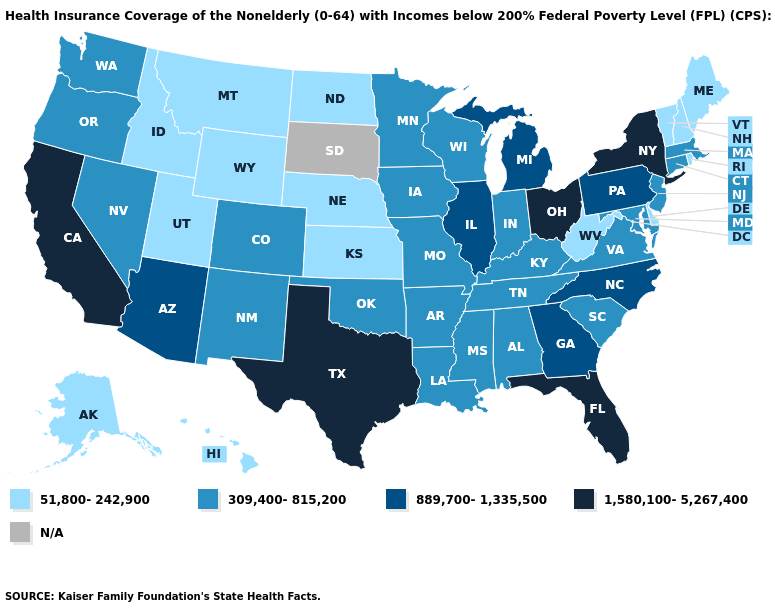Among the states that border Nebraska , does Wyoming have the highest value?
Write a very short answer. No. What is the lowest value in the USA?
Answer briefly. 51,800-242,900. What is the value of Colorado?
Write a very short answer. 309,400-815,200. What is the lowest value in states that border Alabama?
Quick response, please. 309,400-815,200. Name the states that have a value in the range N/A?
Keep it brief. South Dakota. What is the highest value in the USA?
Answer briefly. 1,580,100-5,267,400. What is the highest value in the USA?
Be succinct. 1,580,100-5,267,400. Which states have the lowest value in the USA?
Be succinct. Alaska, Delaware, Hawaii, Idaho, Kansas, Maine, Montana, Nebraska, New Hampshire, North Dakota, Rhode Island, Utah, Vermont, West Virginia, Wyoming. Name the states that have a value in the range 51,800-242,900?
Keep it brief. Alaska, Delaware, Hawaii, Idaho, Kansas, Maine, Montana, Nebraska, New Hampshire, North Dakota, Rhode Island, Utah, Vermont, West Virginia, Wyoming. What is the value of Maine?
Answer briefly. 51,800-242,900. Name the states that have a value in the range 309,400-815,200?
Give a very brief answer. Alabama, Arkansas, Colorado, Connecticut, Indiana, Iowa, Kentucky, Louisiana, Maryland, Massachusetts, Minnesota, Mississippi, Missouri, Nevada, New Jersey, New Mexico, Oklahoma, Oregon, South Carolina, Tennessee, Virginia, Washington, Wisconsin. Does Kentucky have the lowest value in the USA?
Answer briefly. No. Does Iowa have the lowest value in the MidWest?
Quick response, please. No. What is the highest value in states that border Pennsylvania?
Concise answer only. 1,580,100-5,267,400. Among the states that border Indiana , does Kentucky have the lowest value?
Quick response, please. Yes. 